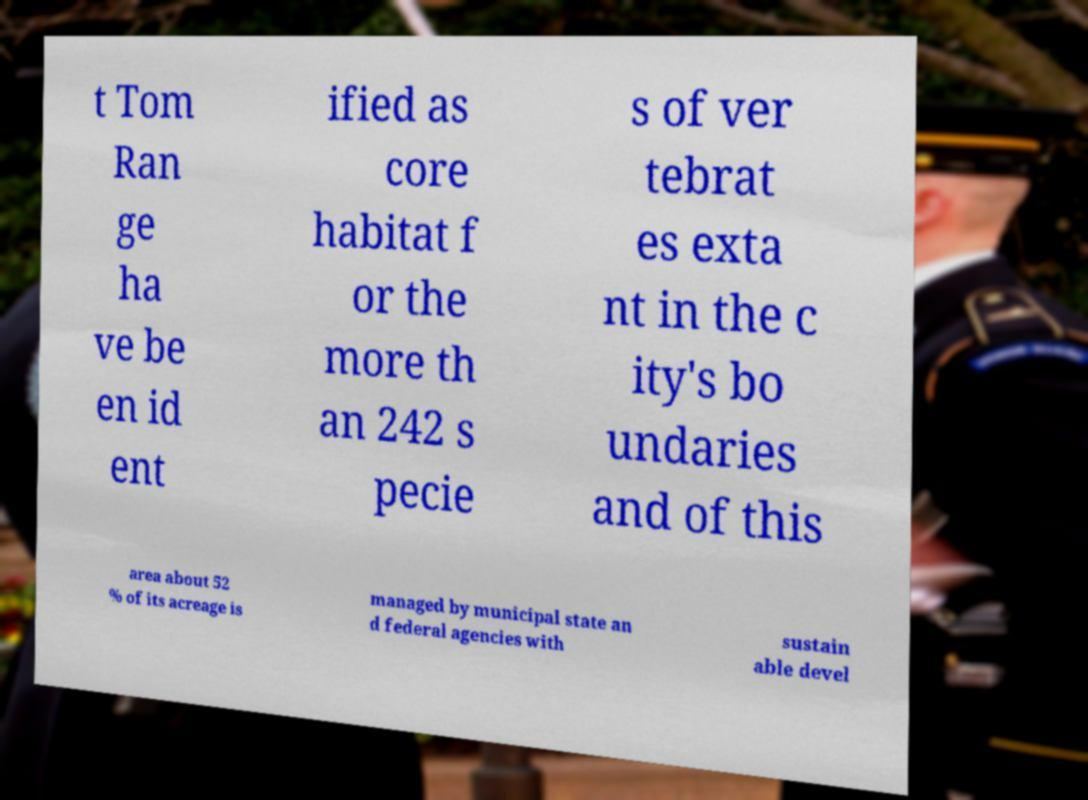Can you accurately transcribe the text from the provided image for me? t Tom Ran ge ha ve be en id ent ified as core habitat f or the more th an 242 s pecie s of ver tebrat es exta nt in the c ity's bo undaries and of this area about 52 % of its acreage is managed by municipal state an d federal agencies with sustain able devel 